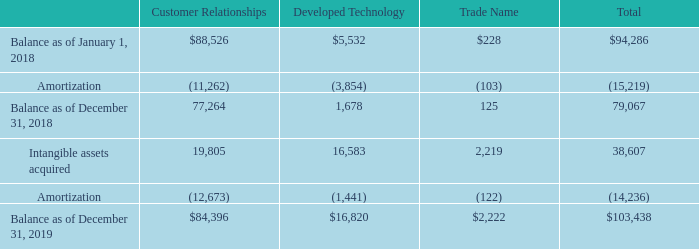Note 8. Goodwill and Intangible Assets, Net
The following table reflects changes in the net carrying amount of the components of intangible assets (in thousands):
What was the amount of Amortization from Customer Relationships in 2018?
Answer scale should be: thousand. (11,262). What was the total balance as of January 1, 2018?
Answer scale should be: thousand. $94,286. What were the total Intangible assets acquired?
Answer scale should be: thousand. 38,607. What was the change in the total balance between December 31, 2019 and December 31, 2018?
Answer scale should be: thousand. 103,438-79,067
Answer: 24371. How many components of intangible assets had a total that exceeded $50,000 thousand as of December 31, 2019? Customer Relationships
Answer: 1. What was the percentage change in the total balance between January 1, 2018 and December 31, 2018? 
Answer scale should be: percent. (79,067-94,286)/94,286
Answer: -16.14. 